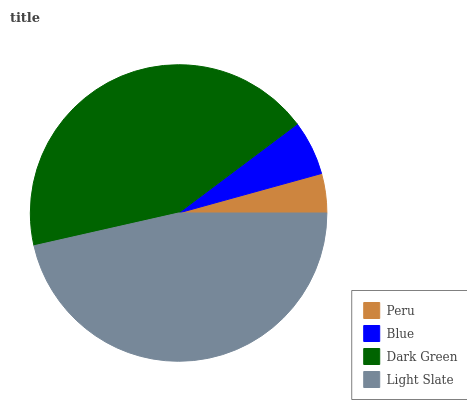Is Peru the minimum?
Answer yes or no. Yes. Is Light Slate the maximum?
Answer yes or no. Yes. Is Blue the minimum?
Answer yes or no. No. Is Blue the maximum?
Answer yes or no. No. Is Blue greater than Peru?
Answer yes or no. Yes. Is Peru less than Blue?
Answer yes or no. Yes. Is Peru greater than Blue?
Answer yes or no. No. Is Blue less than Peru?
Answer yes or no. No. Is Dark Green the high median?
Answer yes or no. Yes. Is Blue the low median?
Answer yes or no. Yes. Is Peru the high median?
Answer yes or no. No. Is Peru the low median?
Answer yes or no. No. 